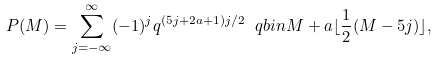Convert formula to latex. <formula><loc_0><loc_0><loc_500><loc_500>P ( M ) = \sum _ { j = - \infty } ^ { \infty } ( - 1 ) ^ { j } q ^ { ( 5 j + 2 a + 1 ) j / 2 } \ q b i n { M + a } { \lfloor \frac { 1 } { 2 } ( M - 5 j ) \rfloor } ,</formula> 